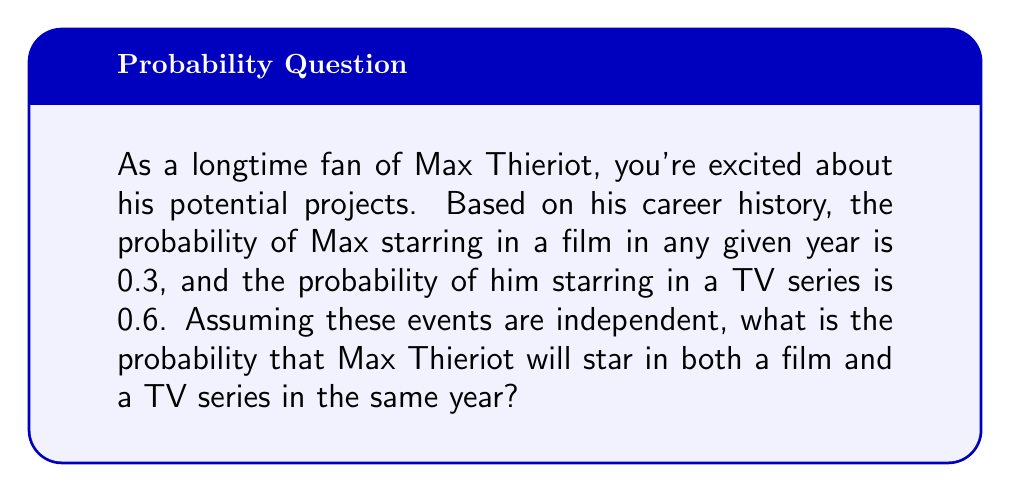Can you answer this question? To solve this problem, we need to use the multiplication rule for independent events. Since we're told that the events are independent, we can multiply the individual probabilities to find the probability of both events occurring.

Let's define our events:
$A$ = Max Thieriot stars in a film
$B$ = Max Thieriot stars in a TV series

Given:
$P(A) = 0.3$
$P(B) = 0.6$

We want to find $P(A \text{ and } B)$, which is the probability of both events occurring.

For independent events:
$$P(A \text{ and } B) = P(A) \times P(B)$$

Substituting our values:
$$P(A \text{ and } B) = 0.3 \times 0.6$$

Calculating:
$$P(A \text{ and } B) = 0.18$$

Therefore, the probability that Max Thieriot will star in both a film and a TV series in the same year is 0.18 or 18%.
Answer: $0.18$ or $18\%$ 